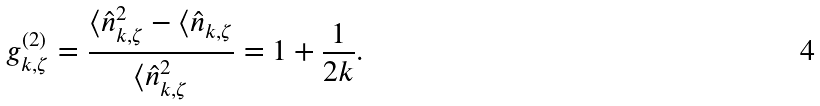<formula> <loc_0><loc_0><loc_500><loc_500>g ^ { ( 2 ) } _ { k , \zeta } = \frac { \langle \hat { n } ^ { 2 } _ { k , \zeta } - \langle \hat { n } _ { k , \zeta } } { \langle \hat { n } _ { k , \zeta } ^ { 2 } } = 1 + \frac { 1 } { 2 k } .</formula> 